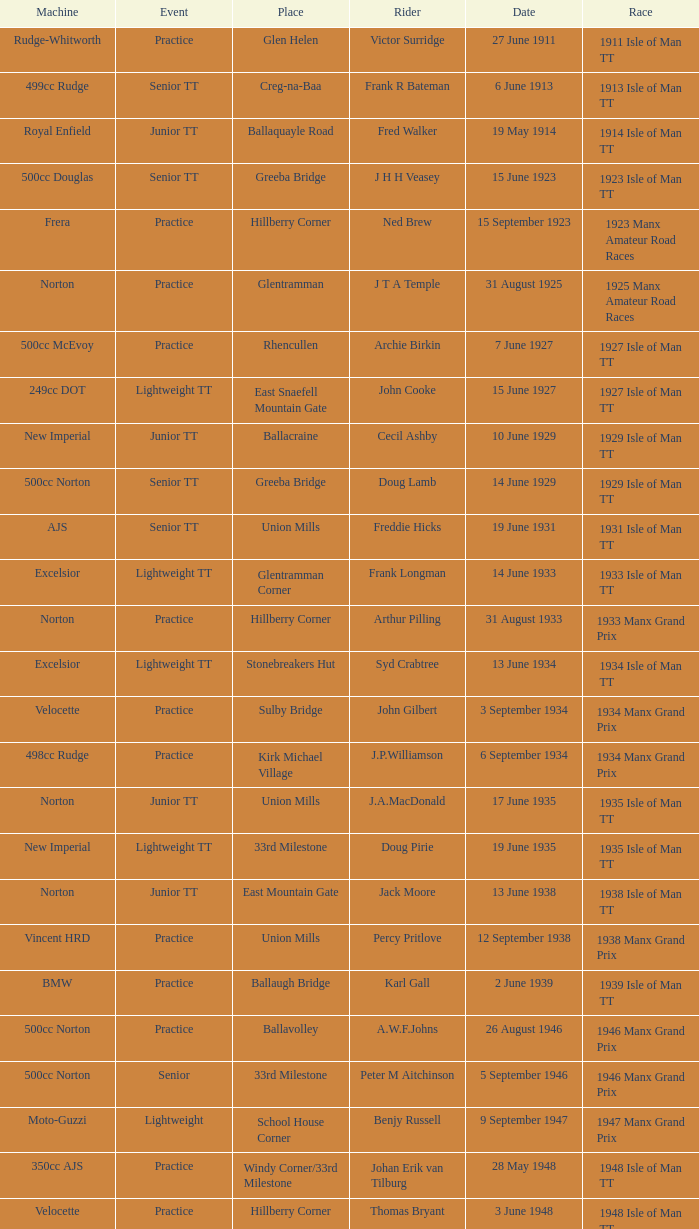What event was Rob Vine riding? Senior TT. 